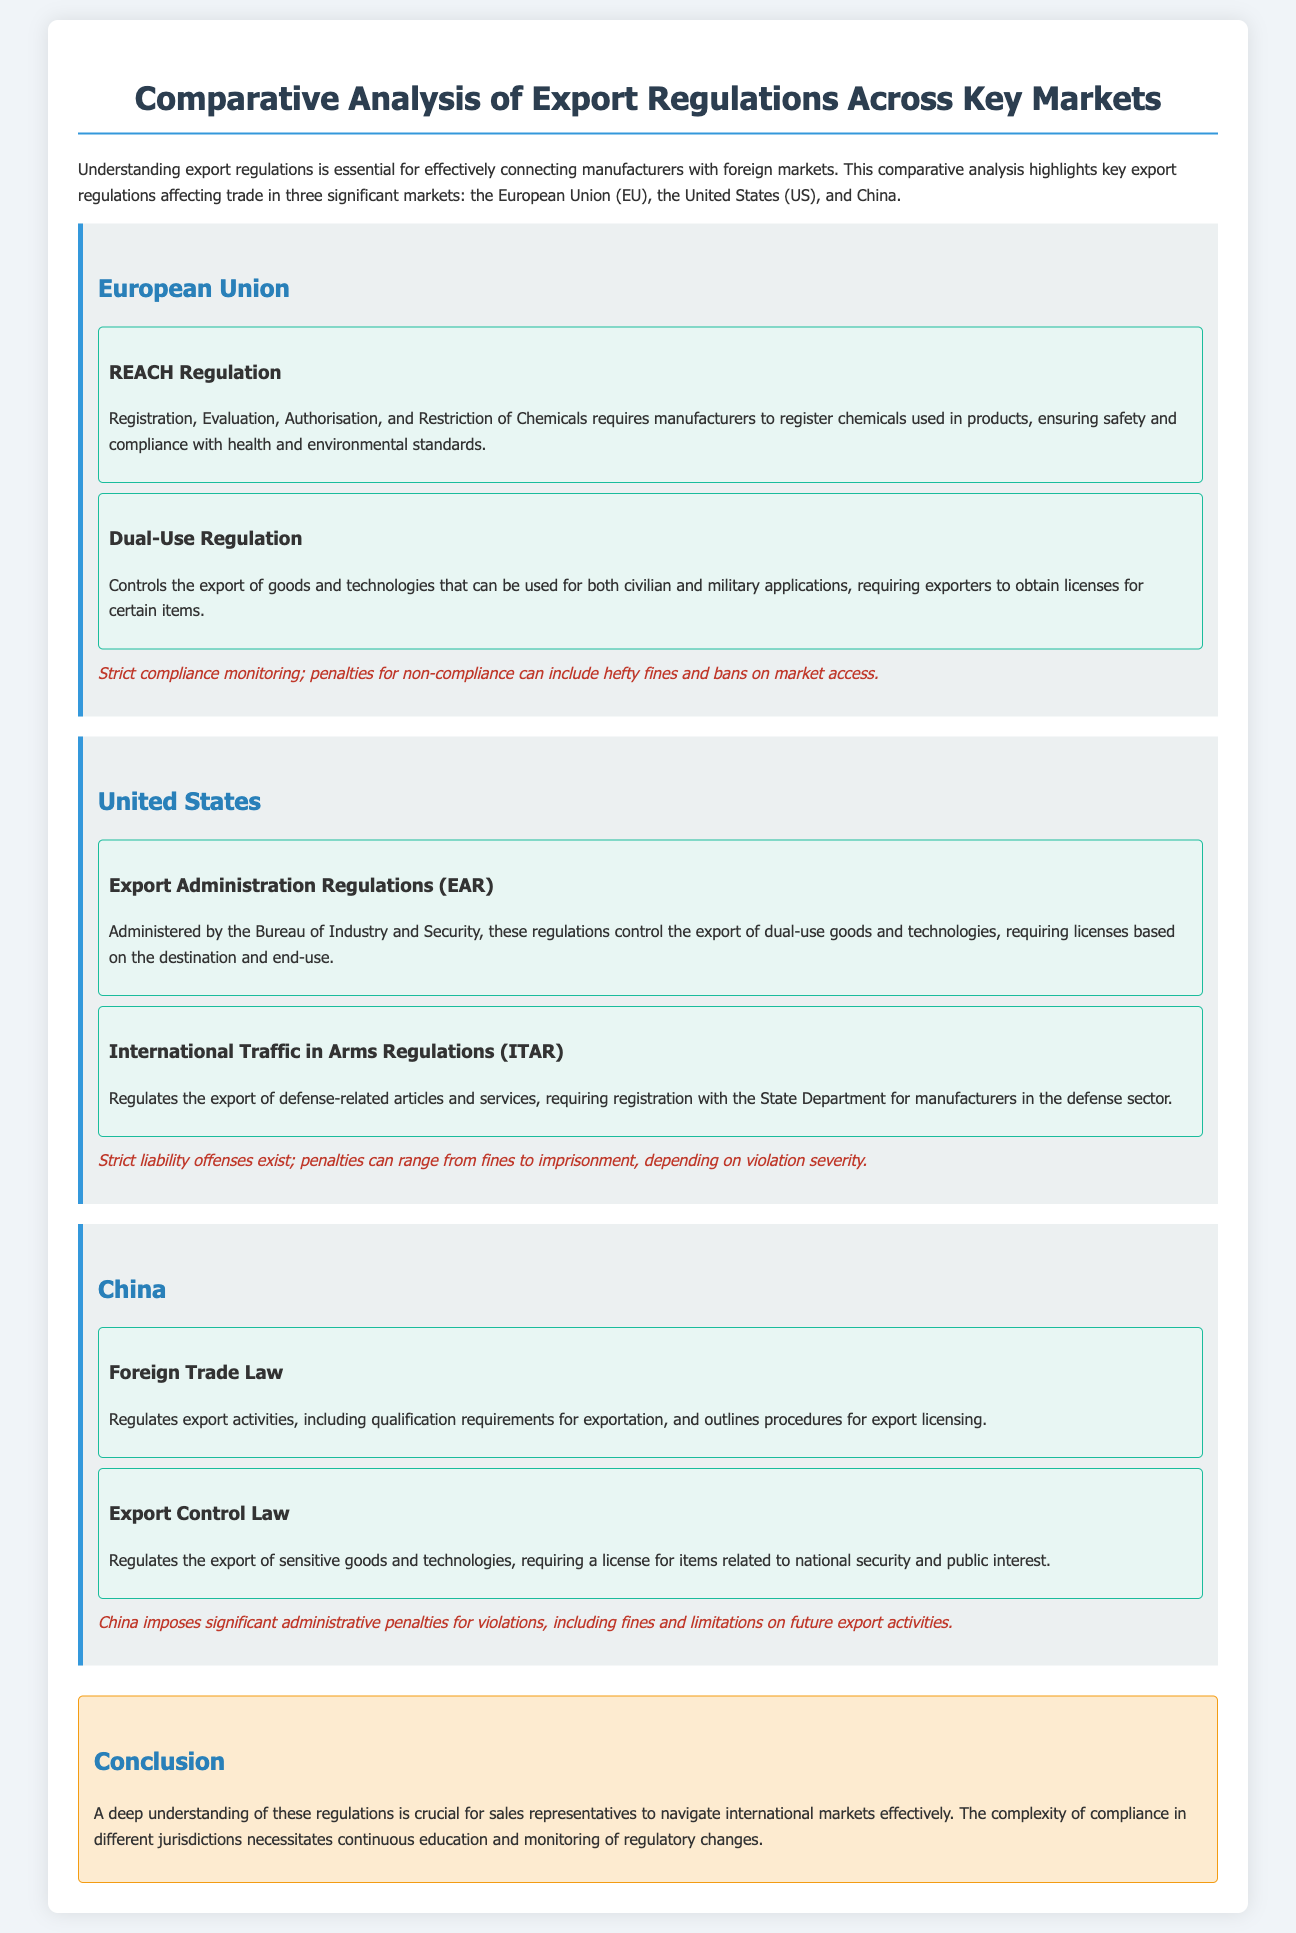What is the regulation concerning chemicals in the EU? The regulation regarding chemicals in the EU is the REACH Regulation which mandates the registration, evaluation, authorization, and restriction of chemicals.
Answer: REACH Regulation What is the name of the regulations governing defense-related exports in the US? The regulations governing defense-related exports in the US are known as the International Traffic in Arms Regulations.
Answer: ITAR What are the two key regulations mentioned for China? The two key regulations for China are the Foreign Trade Law and the Export Control Law.
Answer: Foreign Trade Law and Export Control Law What does the Dual-Use Regulation in the EU control? The Dual-Use Regulation controls the export of goods and technologies that can be used for both civilian and military applications.
Answer: Export of dual-use goods and technologies What is the potential penalty for non-compliance with US regulations? Penalties for non-compliance with US regulations can range from fines to imprisonment, depending on the severity of the violation.
Answer: Fines to imprisonment What is required for export activities under China's Foreign Trade Law? The Foreign Trade Law requires qualification for exportation and outlines procedures for export licensing.
Answer: Qualification requirements for exportation What is a significant consequence of violating China's export regulations? A significant consequence of violating China's export regulations includes significant administrative penalties such as fines and limitations on future export activities.
Answer: Significant administrative penalties What is emphasized in the conclusion regarding understanding export regulations? The conclusion emphasizes the necessity of a deep understanding of regulations for effective navigation in international markets.
Answer: Deep understanding of regulations What does REACH stand for? REACH stands for Registration, Evaluation, Authorisation, and Restriction of Chemicals.
Answer: Registration, Evaluation, Authorisation, and Restriction of Chemicals 